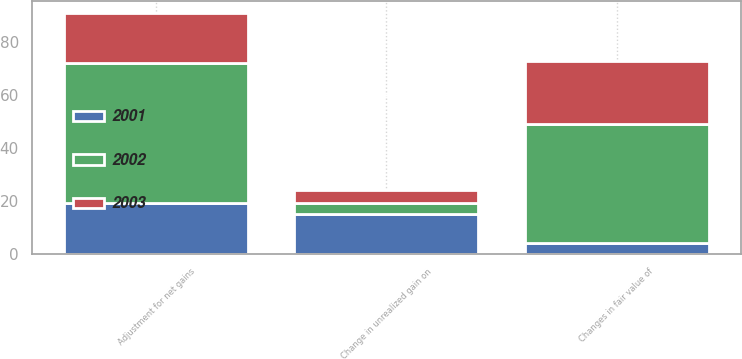<chart> <loc_0><loc_0><loc_500><loc_500><stacked_bar_chart><ecel><fcel>Changes in fair value of<fcel>Adjustment for net gains<fcel>Change in unrealized gain on<nl><fcel>2003<fcel>24<fcel>19<fcel>5<nl><fcel>2001<fcel>4<fcel>19<fcel>15<nl><fcel>2002<fcel>45<fcel>53<fcel>4<nl></chart> 